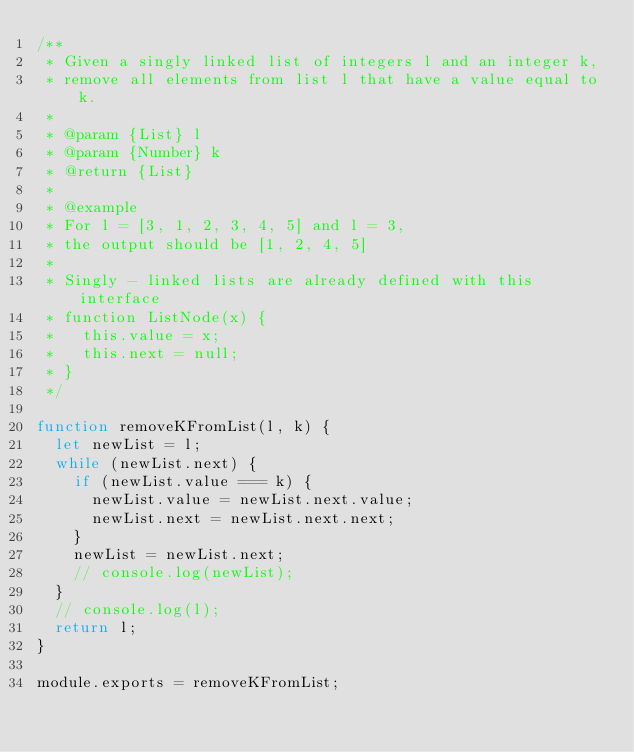<code> <loc_0><loc_0><loc_500><loc_500><_JavaScript_>/**
 * Given a singly linked list of integers l and an integer k,
 * remove all elements from list l that have a value equal to k.
 *
 * @param {List} l
 * @param {Number} k
 * @return {List}
 *
 * @example
 * For l = [3, 1, 2, 3, 4, 5] and l = 3,
 * the output should be [1, 2, 4, 5]
 *
 * Singly - linked lists are already defined with this interface
 * function ListNode(x) {
 *   this.value = x;
 *   this.next = null;
 * }
 */

function removeKFromList(l, k) {
  let newList = l;
  while (newList.next) {
    if (newList.value === k) {
      newList.value = newList.next.value;
      newList.next = newList.next.next;
    }
    newList = newList.next;
    // console.log(newList);
  }
  // console.log(l);
  return l;
}

module.exports = removeKFromList;
</code> 